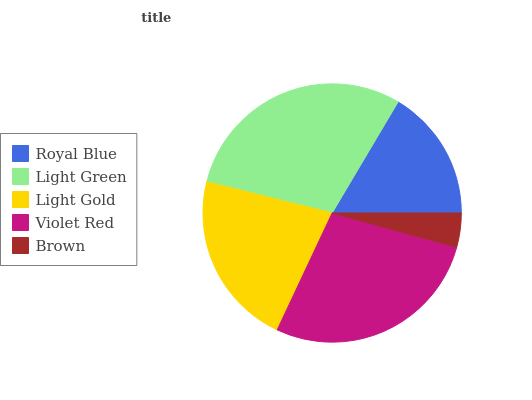Is Brown the minimum?
Answer yes or no. Yes. Is Light Green the maximum?
Answer yes or no. Yes. Is Light Gold the minimum?
Answer yes or no. No. Is Light Gold the maximum?
Answer yes or no. No. Is Light Green greater than Light Gold?
Answer yes or no. Yes. Is Light Gold less than Light Green?
Answer yes or no. Yes. Is Light Gold greater than Light Green?
Answer yes or no. No. Is Light Green less than Light Gold?
Answer yes or no. No. Is Light Gold the high median?
Answer yes or no. Yes. Is Light Gold the low median?
Answer yes or no. Yes. Is Royal Blue the high median?
Answer yes or no. No. Is Royal Blue the low median?
Answer yes or no. No. 